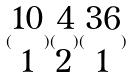Convert formula to latex. <formula><loc_0><loc_0><loc_500><loc_500>( \begin{matrix} 1 0 \\ 1 \end{matrix} ) ( \begin{matrix} 4 \\ 2 \end{matrix} ) ( \begin{matrix} 3 6 \\ 1 \end{matrix} )</formula> 